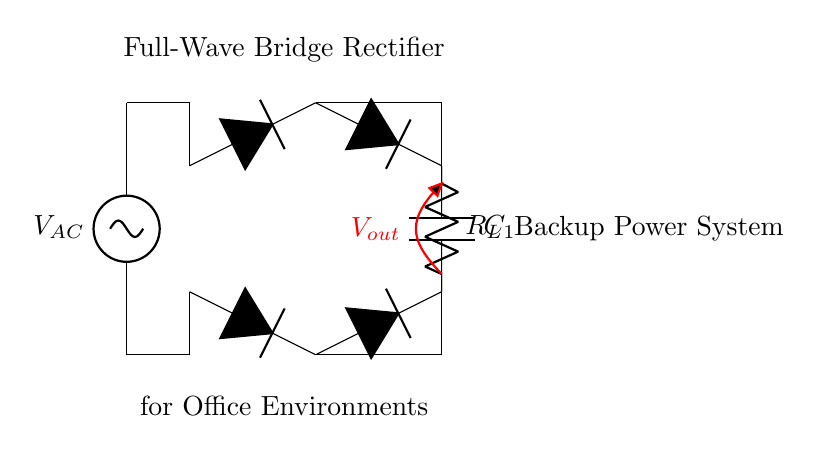What type of rectifier is shown in the diagram? The diagram represents a full-wave bridge rectifier, as indicated by the arrangement of four diodes configured to allow both halves of the AC signal to be used.
Answer: full-wave bridge rectifier What is the value of the load resistor in the circuit? The value of the load resistor is symbolically represented as R_L in the circuit diagram, without a specific numeric value assigned in the visual.
Answer: R_L How many diodes are used in this circuit? There are four diodes in the arrangement of this full-wave bridge rectifier, which is necessary to conduct current for both polarities of the AC signal.
Answer: 4 What component is used to smooth the output voltage? The capacitor labeled C_1 is used to smooth the output voltage, which reduces the ripple in the DC output after rectification.
Answer: C_1 What is the output voltage denoted as in the diagram? The output voltage is denoted as V_out, which is the voltage across the load resistor and capacitor after rectification and filtering.
Answer: V_out Why is a bridge rectifier used instead of a half-wave rectifier? A bridge rectifier is used instead of a half-wave rectifier because it allows for full wave rectification, utilizing both halves of the AC cycle, thus providing a higher average output voltage and more efficient power utilization.
Answer: higher output voltage What is the function of the smoothing capacitor in this rectifier circuit? The smoothing capacitor (C_1) functions to store and release charge, thus reducing voltage ripple in the output and providing a more stable DC voltage for the load.
Answer: reduce voltage ripple 